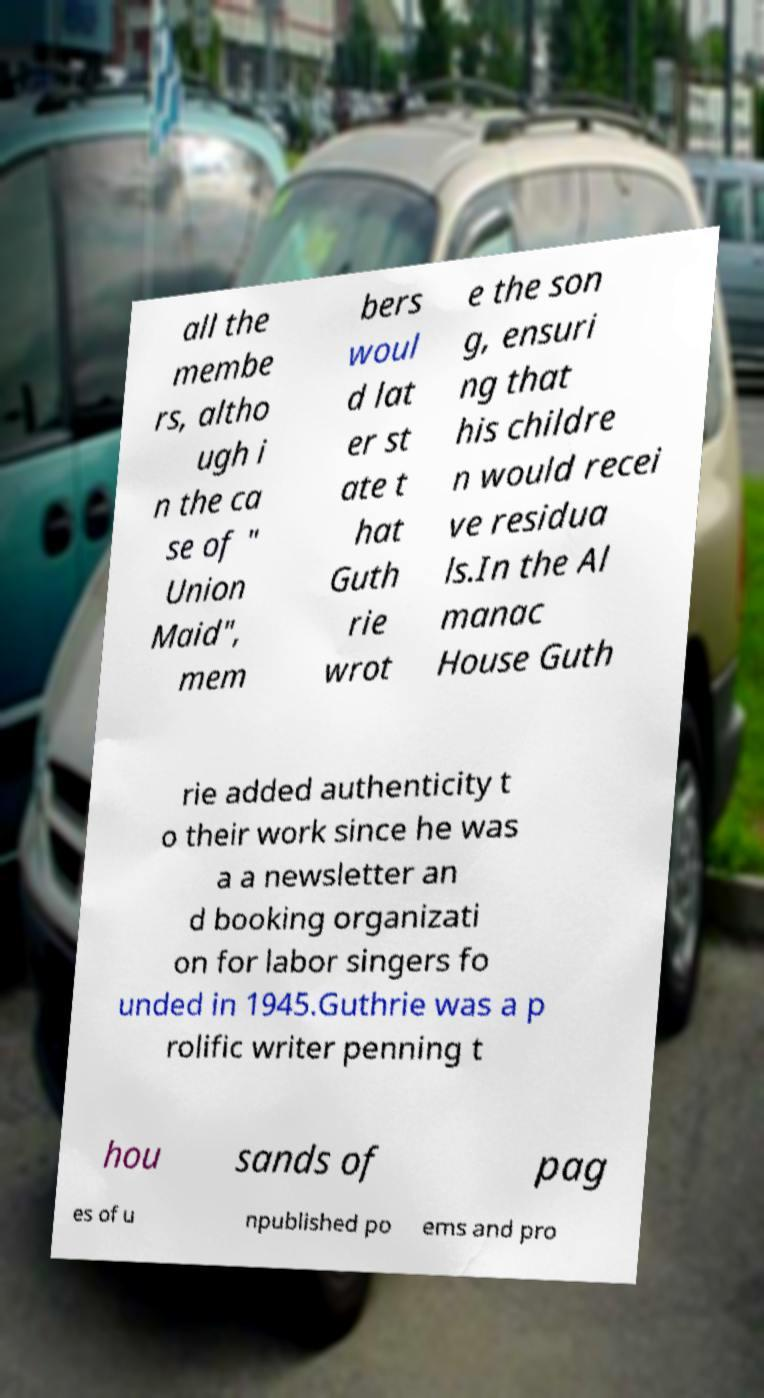Can you accurately transcribe the text from the provided image for me? all the membe rs, altho ugh i n the ca se of " Union Maid", mem bers woul d lat er st ate t hat Guth rie wrot e the son g, ensuri ng that his childre n would recei ve residua ls.In the Al manac House Guth rie added authenticity t o their work since he was a a newsletter an d booking organizati on for labor singers fo unded in 1945.Guthrie was a p rolific writer penning t hou sands of pag es of u npublished po ems and pro 